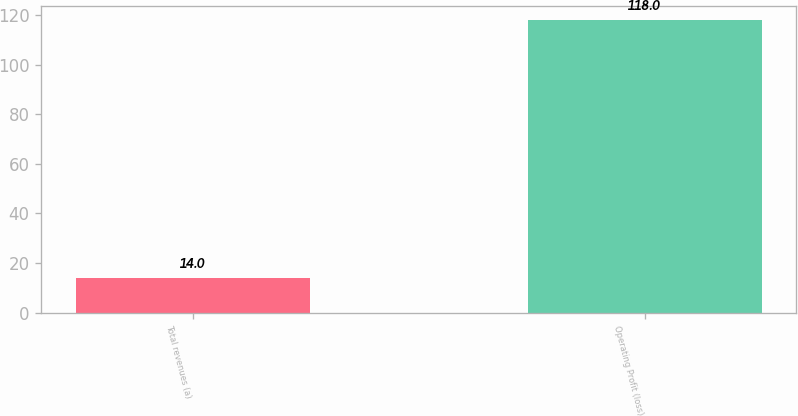<chart> <loc_0><loc_0><loc_500><loc_500><bar_chart><fcel>Total revenues (a)<fcel>Operating Profit (loss)<nl><fcel>14<fcel>118<nl></chart> 